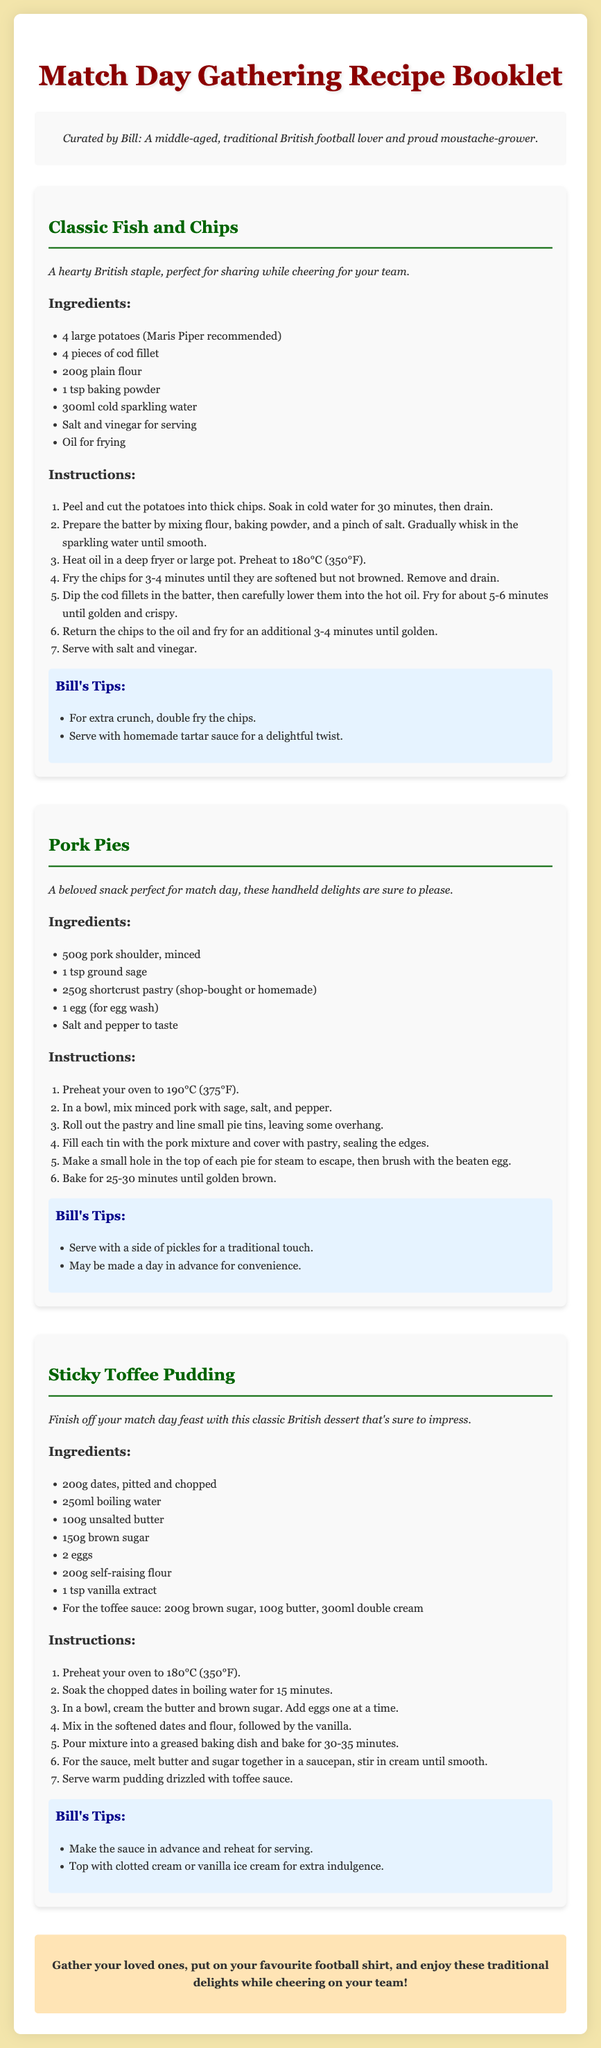What is the title of the booklet? The title of the booklet is prominently displayed at the top of the document.
Answer: Match Day Gathering Recipe Booklet Who curated the booklet? The document includes a persona section which states who curated it.
Answer: Bill What is the first recipe listed? The recipes are listed in order, and the first recipe is mentioned under the recipe section.
Answer: Classic Fish and Chips How many ingredients are needed for Pork Pies? The ingredients for Pork Pies are listed clearly, allowing for an easy count.
Answer: 5 What is the cooking temperature for Sticky Toffee Pudding? The instructions for Sticky Toffee Pudding specify the temperature needed for baking.
Answer: 180°C (350°F) Which ingredient is used for the toffee sauce? The toffee sauce ingredients are listed under Sticky Toffee Pudding, providing specific items needed.
Answer: Brown sugar What is one of Bill's tips for Fish and Chips? The tips section for Fish and Chips includes suggestions unique to Bill.
Answer: Double fry the chips How long should the Pork Pies bake? The baking time for Pork Pies is explicitly stated in the instructions.
Answer: 25-30 minutes What should you serve the Sticky Toffee Pudding with? The tips for serving the pudding suggest specific accompaniments.
Answer: Clotted cream or vanilla ice cream 